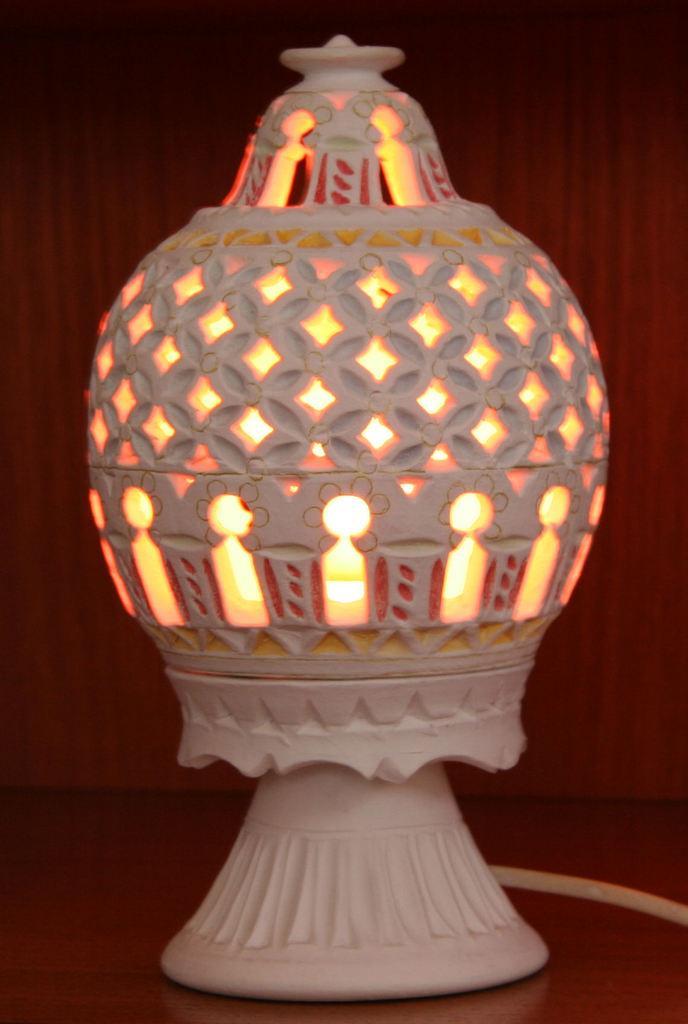Please provide a concise description of this image. In this image we can see a lamp on the wooden surface. It seems like a wooden wall in the background. 